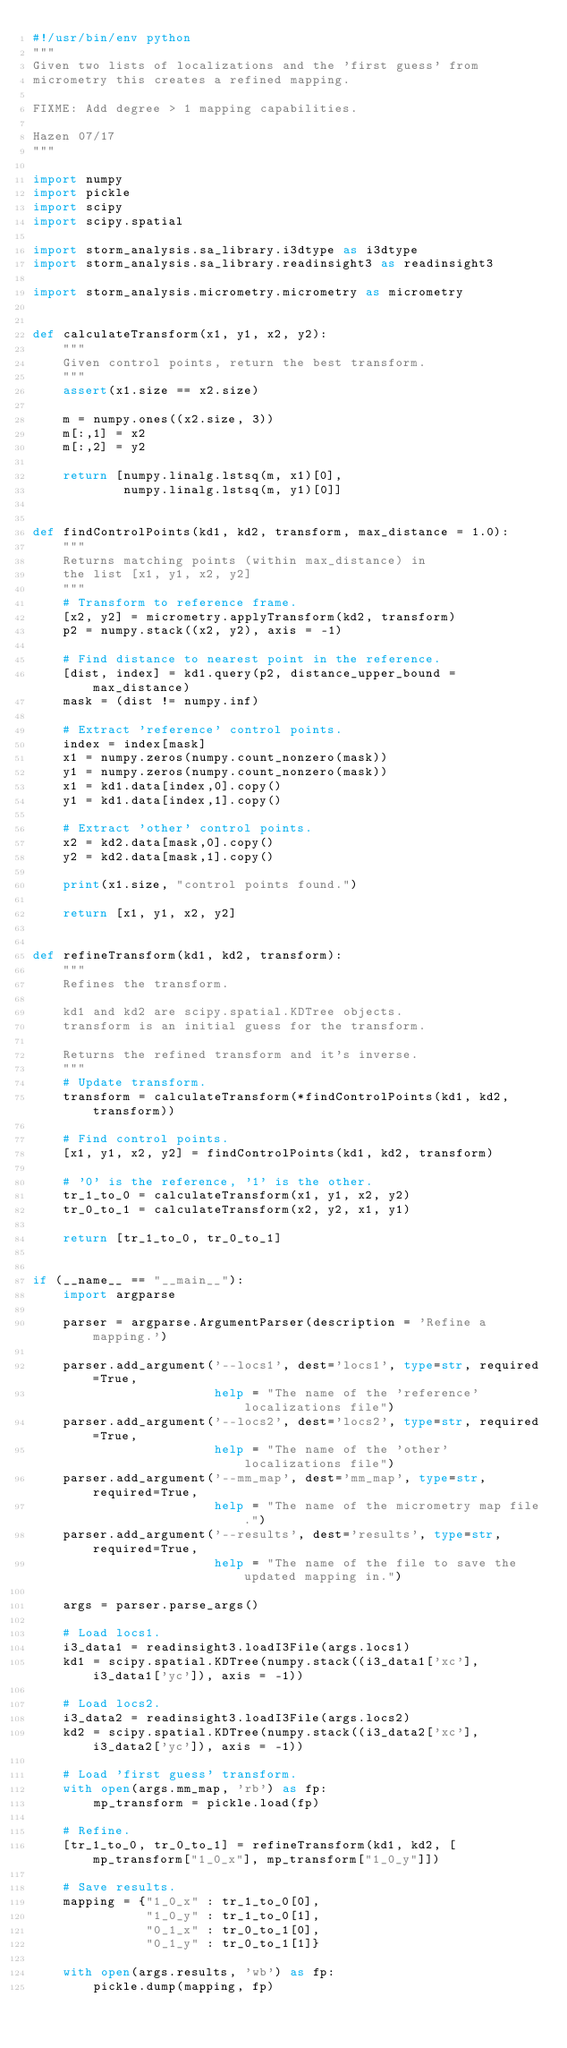Convert code to text. <code><loc_0><loc_0><loc_500><loc_500><_Python_>#!/usr/bin/env python
"""
Given two lists of localizations and the 'first guess' from
micrometry this creates a refined mapping.

FIXME: Add degree > 1 mapping capabilities.

Hazen 07/17
"""

import numpy
import pickle
import scipy
import scipy.spatial

import storm_analysis.sa_library.i3dtype as i3dtype
import storm_analysis.sa_library.readinsight3 as readinsight3

import storm_analysis.micrometry.micrometry as micrometry


def calculateTransform(x1, y1, x2, y2):
    """
    Given control points, return the best transform.
    """
    assert(x1.size == x2.size)
    
    m = numpy.ones((x2.size, 3))
    m[:,1] = x2
    m[:,2] = y2

    return [numpy.linalg.lstsq(m, x1)[0],
            numpy.linalg.lstsq(m, y1)[0]]

    
def findControlPoints(kd1, kd2, transform, max_distance = 1.0):
    """
    Returns matching points (within max_distance) in 
    the list [x1, y1, x2, y2]
    """
    # Transform to reference frame.
    [x2, y2] = micrometry.applyTransform(kd2, transform)
    p2 = numpy.stack((x2, y2), axis = -1)

    # Find distance to nearest point in the reference.
    [dist, index] = kd1.query(p2, distance_upper_bound = max_distance)
    mask = (dist != numpy.inf)

    # Extract 'reference' control points.
    index = index[mask]
    x1 = numpy.zeros(numpy.count_nonzero(mask))
    y1 = numpy.zeros(numpy.count_nonzero(mask))
    x1 = kd1.data[index,0].copy()
    y1 = kd1.data[index,1].copy()
    
    # Extract 'other' control points.
    x2 = kd2.data[mask,0].copy()
    y2 = kd2.data[mask,1].copy()

    print(x1.size, "control points found.")
    
    return [x1, y1, x2, y2]


def refineTransform(kd1, kd2, transform):
    """
    Refines the transform.

    kd1 and kd2 are scipy.spatial.KDTree objects.
    transform is an initial guess for the transform.
    
    Returns the refined transform and it's inverse.
    """
    # Update transform.
    transform = calculateTransform(*findControlPoints(kd1, kd2, transform))

    # Find control points.
    [x1, y1, x2, y2] = findControlPoints(kd1, kd2, transform)

    # '0' is the reference, '1' is the other.
    tr_1_to_0 = calculateTransform(x1, y1, x2, y2)
    tr_0_to_1 = calculateTransform(x2, y2, x1, y1)

    return [tr_1_to_0, tr_0_to_1]
    

if (__name__ == "__main__"):
    import argparse

    parser = argparse.ArgumentParser(description = 'Refine a mapping.')

    parser.add_argument('--locs1', dest='locs1', type=str, required=True,
                        help = "The name of the 'reference' localizations file")
    parser.add_argument('--locs2', dest='locs2', type=str, required=True,
                        help = "The name of the 'other' localizations file")
    parser.add_argument('--mm_map', dest='mm_map', type=str, required=True,
                        help = "The name of the micrometry map file.")
    parser.add_argument('--results', dest='results', type=str, required=True,
                        help = "The name of the file to save the updated mapping in.")

    args = parser.parse_args()

    # Load locs1.
    i3_data1 = readinsight3.loadI3File(args.locs1)
    kd1 = scipy.spatial.KDTree(numpy.stack((i3_data1['xc'], i3_data1['yc']), axis = -1))

    # Load locs2.
    i3_data2 = readinsight3.loadI3File(args.locs2)
    kd2 = scipy.spatial.KDTree(numpy.stack((i3_data2['xc'], i3_data2['yc']), axis = -1))

    # Load 'first guess' transform.
    with open(args.mm_map, 'rb') as fp:
        mp_transform = pickle.load(fp)

    # Refine.
    [tr_1_to_0, tr_0_to_1] = refineTransform(kd1, kd2, [mp_transform["1_0_x"], mp_transform["1_0_y"]])

    # Save results.
    mapping = {"1_0_x" : tr_1_to_0[0],
               "1_0_y" : tr_1_to_0[1],
               "0_1_x" : tr_0_to_1[0],
               "0_1_y" : tr_0_to_1[1]}

    with open(args.results, 'wb') as fp:
        pickle.dump(mapping, fp)
</code> 